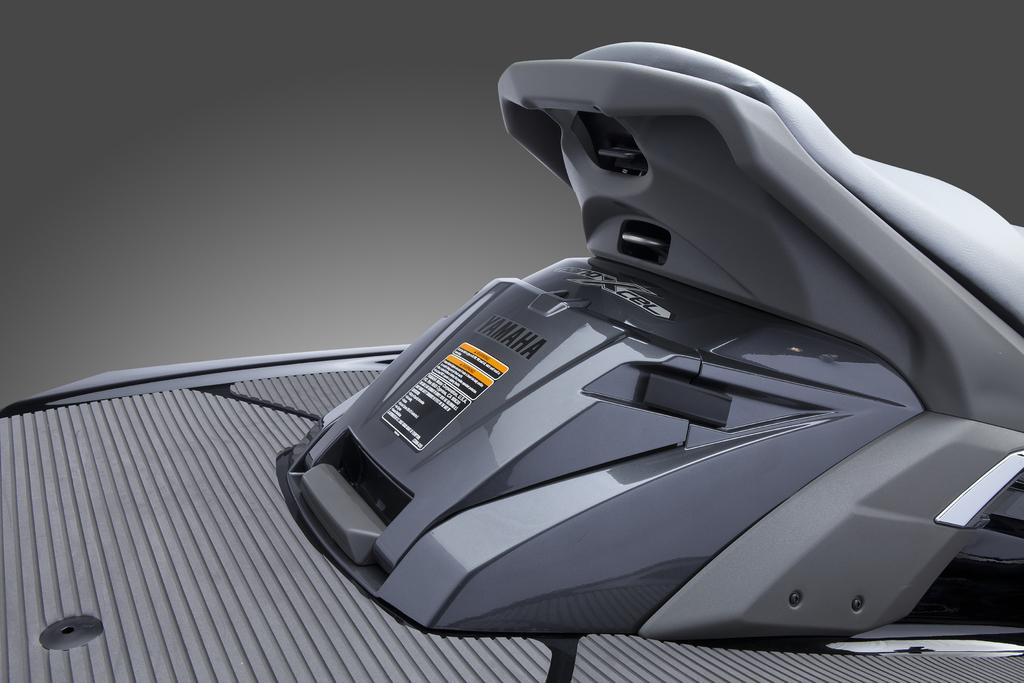What is the main subject of the image? There is a vehicle in the image. Can you describe the color of the vehicle? The vehicle is gray in color. What colors are present in the background of the image? The background of the image is in gray and white colors. How does the vehicle express anger in the image? The vehicle does not express anger in the image, as it is an inanimate object and cannot display emotions. 